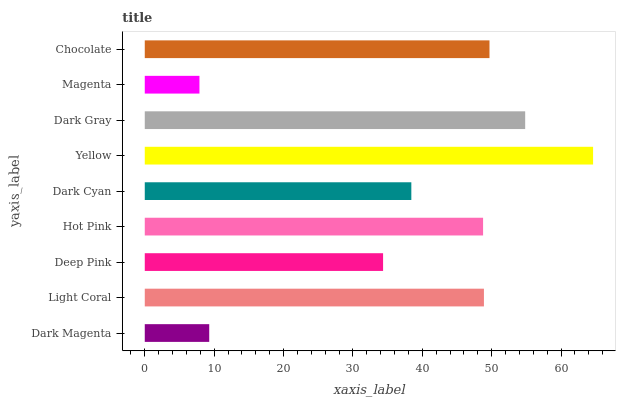Is Magenta the minimum?
Answer yes or no. Yes. Is Yellow the maximum?
Answer yes or no. Yes. Is Light Coral the minimum?
Answer yes or no. No. Is Light Coral the maximum?
Answer yes or no. No. Is Light Coral greater than Dark Magenta?
Answer yes or no. Yes. Is Dark Magenta less than Light Coral?
Answer yes or no. Yes. Is Dark Magenta greater than Light Coral?
Answer yes or no. No. Is Light Coral less than Dark Magenta?
Answer yes or no. No. Is Hot Pink the high median?
Answer yes or no. Yes. Is Hot Pink the low median?
Answer yes or no. Yes. Is Magenta the high median?
Answer yes or no. No. Is Yellow the low median?
Answer yes or no. No. 